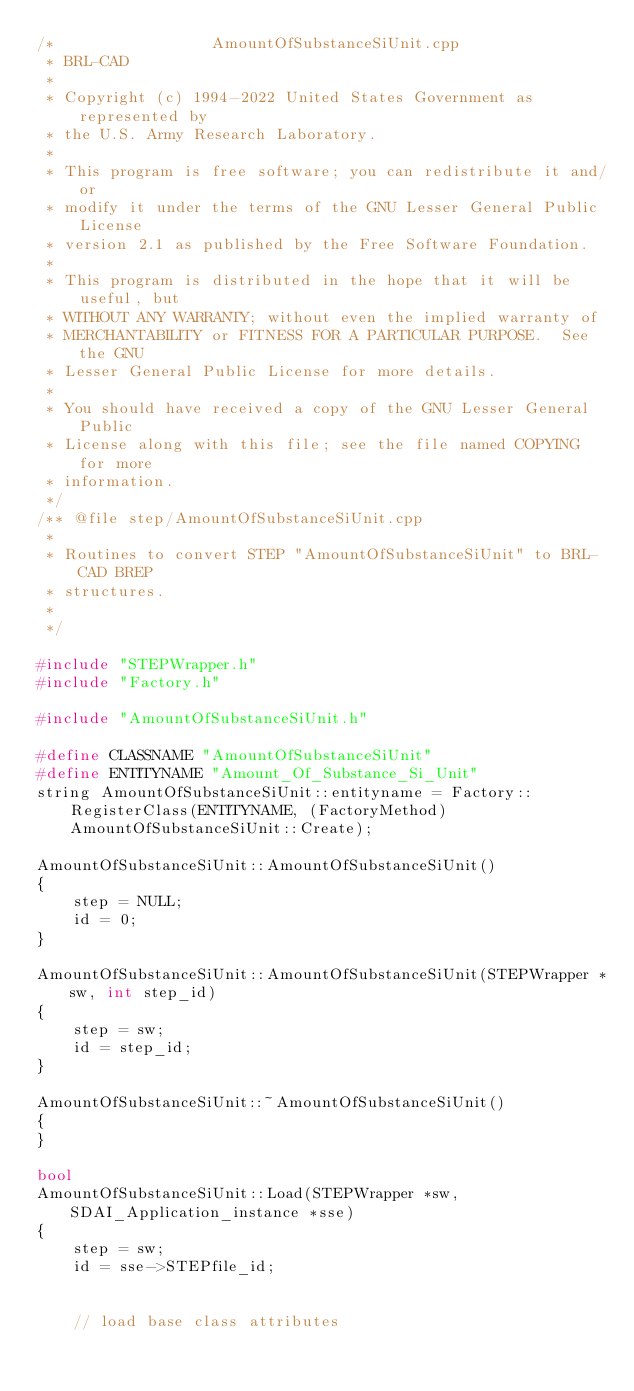<code> <loc_0><loc_0><loc_500><loc_500><_C++_>/*                 AmountOfSubstanceSiUnit.cpp
 * BRL-CAD
 *
 * Copyright (c) 1994-2022 United States Government as represented by
 * the U.S. Army Research Laboratory.
 *
 * This program is free software; you can redistribute it and/or
 * modify it under the terms of the GNU Lesser General Public License
 * version 2.1 as published by the Free Software Foundation.
 *
 * This program is distributed in the hope that it will be useful, but
 * WITHOUT ANY WARRANTY; without even the implied warranty of
 * MERCHANTABILITY or FITNESS FOR A PARTICULAR PURPOSE.  See the GNU
 * Lesser General Public License for more details.
 *
 * You should have received a copy of the GNU Lesser General Public
 * License along with this file; see the file named COPYING for more
 * information.
 */
/** @file step/AmountOfSubstanceSiUnit.cpp
 *
 * Routines to convert STEP "AmountOfSubstanceSiUnit" to BRL-CAD BREP
 * structures.
 *
 */

#include "STEPWrapper.h"
#include "Factory.h"

#include "AmountOfSubstanceSiUnit.h"

#define CLASSNAME "AmountOfSubstanceSiUnit"
#define ENTITYNAME "Amount_Of_Substance_Si_Unit"
string AmountOfSubstanceSiUnit::entityname = Factory::RegisterClass(ENTITYNAME, (FactoryMethod)AmountOfSubstanceSiUnit::Create);

AmountOfSubstanceSiUnit::AmountOfSubstanceSiUnit()
{
    step = NULL;
    id = 0;
}

AmountOfSubstanceSiUnit::AmountOfSubstanceSiUnit(STEPWrapper *sw, int step_id)
{
    step = sw;
    id = step_id;
}

AmountOfSubstanceSiUnit::~AmountOfSubstanceSiUnit()
{
}

bool
AmountOfSubstanceSiUnit::Load(STEPWrapper *sw, SDAI_Application_instance *sse)
{
    step = sw;
    id = sse->STEPfile_id;


    // load base class attributes</code> 